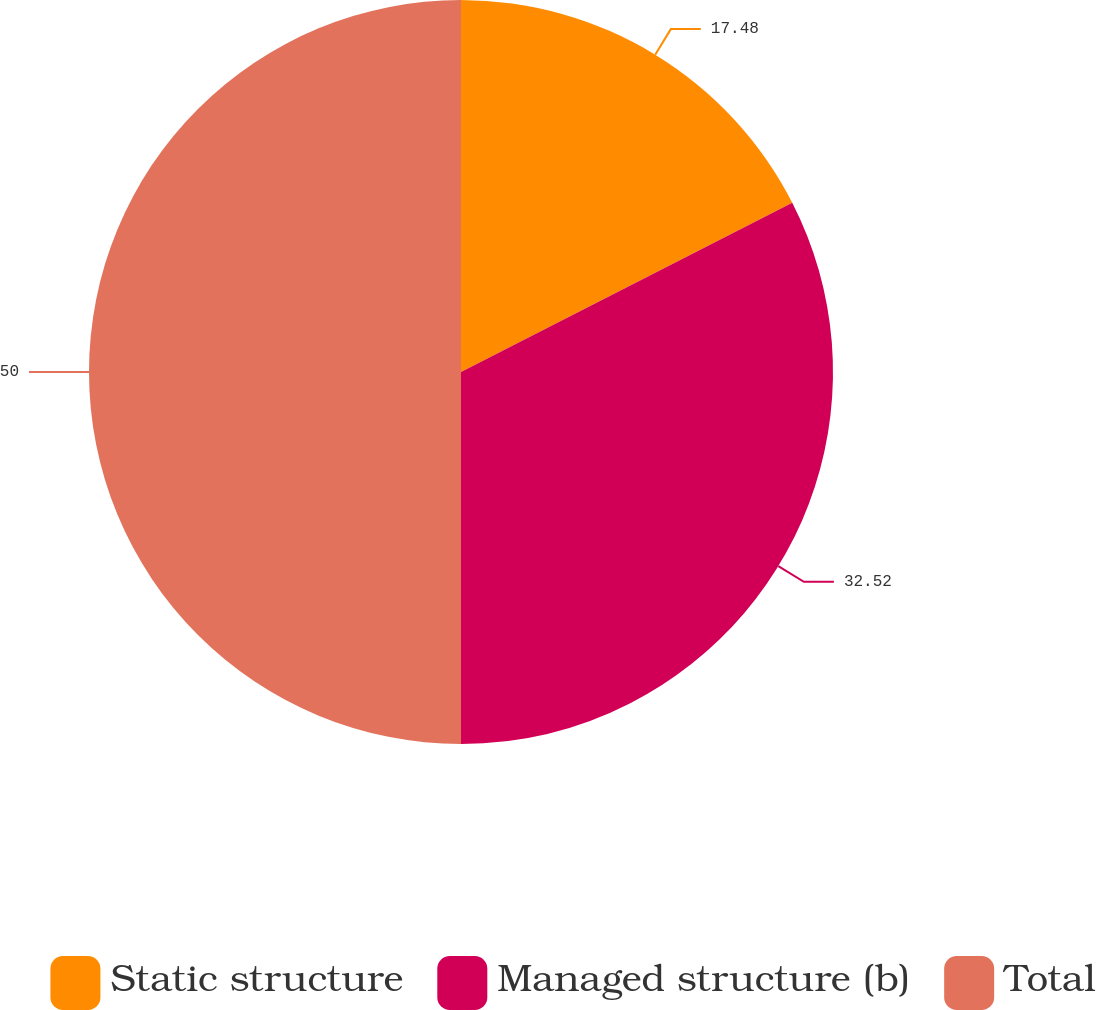Convert chart. <chart><loc_0><loc_0><loc_500><loc_500><pie_chart><fcel>Static structure<fcel>Managed structure (b)<fcel>Total<nl><fcel>17.48%<fcel>32.52%<fcel>50.0%<nl></chart> 